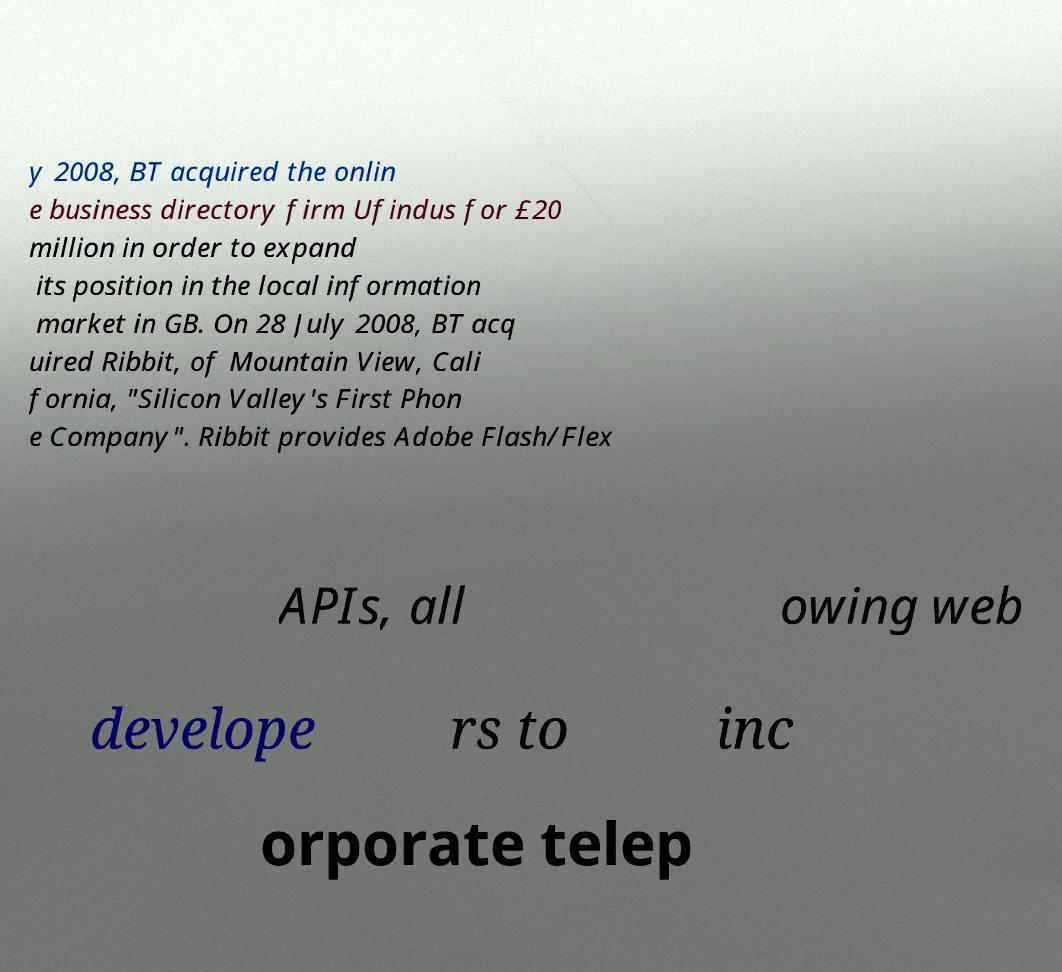Can you accurately transcribe the text from the provided image for me? y 2008, BT acquired the onlin e business directory firm Ufindus for £20 million in order to expand its position in the local information market in GB. On 28 July 2008, BT acq uired Ribbit, of Mountain View, Cali fornia, "Silicon Valley's First Phon e Company". Ribbit provides Adobe Flash/Flex APIs, all owing web develope rs to inc orporate telep 